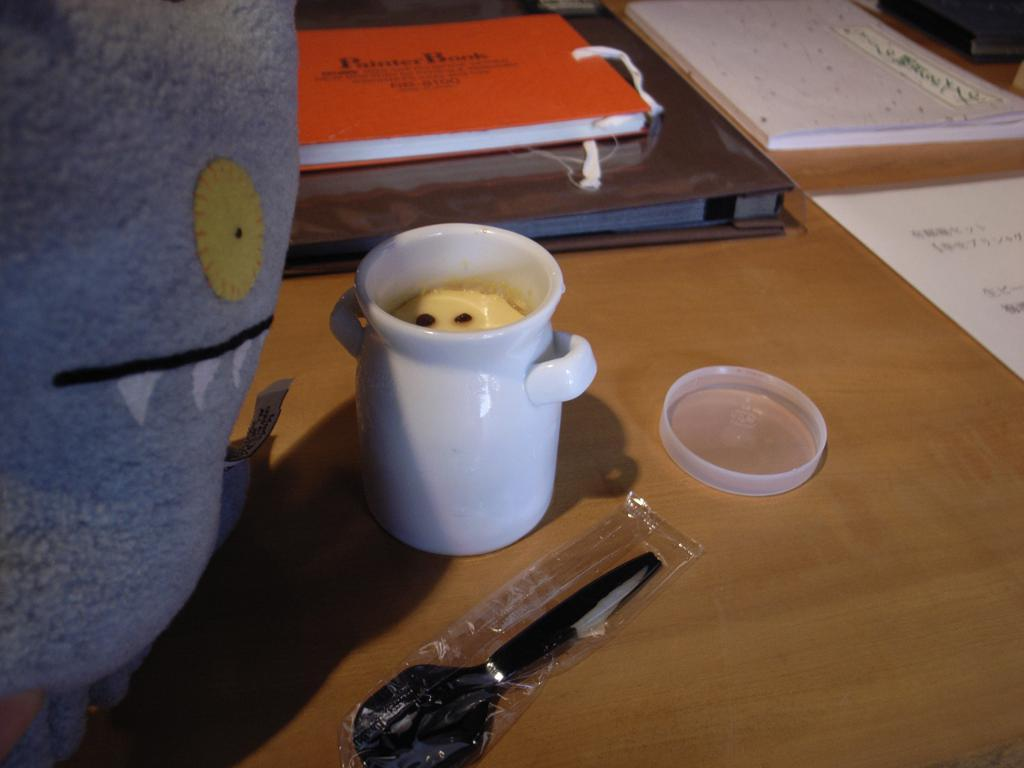What piece of furniture is present in the image? There is a table in the image. What color is the table? The table is yellow. What items can be seen on the table? There are books, a glass, and a spoon on the table. What color is the glass? The glass is white. What color is the spoon? The spoon is black. Is there any smoke coming from the table in the image? No, there is no smoke present in the image. 